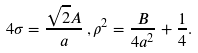<formula> <loc_0><loc_0><loc_500><loc_500>4 \sigma = \frac { \sqrt { 2 } A } { a } \, , \rho ^ { 2 } = \frac { B } { 4 a ^ { 2 } } + \frac { 1 } { 4 } .</formula> 